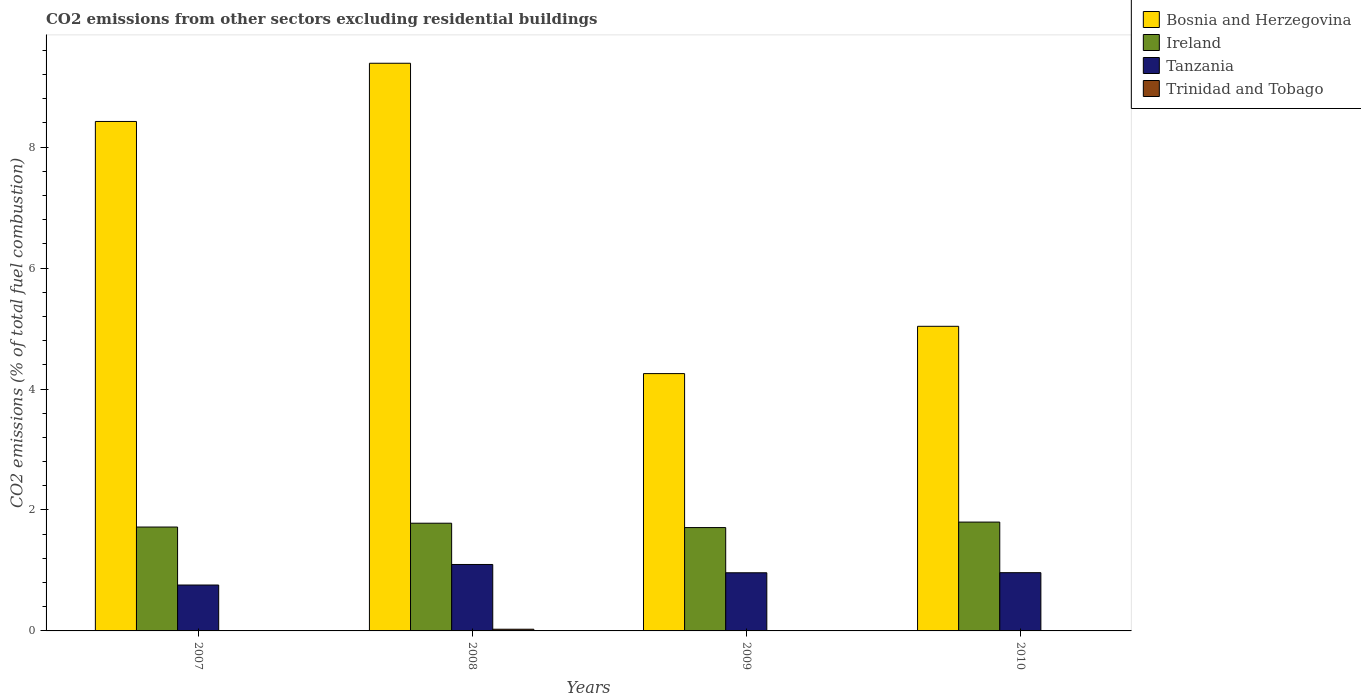How many groups of bars are there?
Provide a short and direct response. 4. What is the total CO2 emitted in Tanzania in 2007?
Offer a very short reply. 0.76. Across all years, what is the maximum total CO2 emitted in Trinidad and Tobago?
Your answer should be very brief. 0.03. Across all years, what is the minimum total CO2 emitted in Trinidad and Tobago?
Provide a succinct answer. 0. In which year was the total CO2 emitted in Trinidad and Tobago maximum?
Provide a succinct answer. 2008. What is the total total CO2 emitted in Tanzania in the graph?
Offer a very short reply. 3.78. What is the difference between the total CO2 emitted in Tanzania in 2008 and that in 2010?
Make the answer very short. 0.14. What is the difference between the total CO2 emitted in Ireland in 2008 and the total CO2 emitted in Trinidad and Tobago in 2010?
Make the answer very short. 1.78. What is the average total CO2 emitted in Trinidad and Tobago per year?
Your response must be concise. 0.01. In the year 2008, what is the difference between the total CO2 emitted in Tanzania and total CO2 emitted in Ireland?
Offer a very short reply. -0.68. What is the ratio of the total CO2 emitted in Tanzania in 2007 to that in 2009?
Your answer should be very brief. 0.79. Is the difference between the total CO2 emitted in Tanzania in 2007 and 2008 greater than the difference between the total CO2 emitted in Ireland in 2007 and 2008?
Make the answer very short. No. What is the difference between the highest and the second highest total CO2 emitted in Ireland?
Your answer should be compact. 0.02. What is the difference between the highest and the lowest total CO2 emitted in Tanzania?
Give a very brief answer. 0.34. In how many years, is the total CO2 emitted in Trinidad and Tobago greater than the average total CO2 emitted in Trinidad and Tobago taken over all years?
Your answer should be compact. 1. Is the sum of the total CO2 emitted in Tanzania in 2009 and 2010 greater than the maximum total CO2 emitted in Trinidad and Tobago across all years?
Your response must be concise. Yes. Are all the bars in the graph horizontal?
Keep it short and to the point. No. How many years are there in the graph?
Keep it short and to the point. 4. What is the difference between two consecutive major ticks on the Y-axis?
Your response must be concise. 2. Does the graph contain any zero values?
Give a very brief answer. Yes. Does the graph contain grids?
Your answer should be compact. No. Where does the legend appear in the graph?
Ensure brevity in your answer.  Top right. How many legend labels are there?
Keep it short and to the point. 4. How are the legend labels stacked?
Ensure brevity in your answer.  Vertical. What is the title of the graph?
Your response must be concise. CO2 emissions from other sectors excluding residential buildings. What is the label or title of the Y-axis?
Give a very brief answer. CO2 emissions (% of total fuel combustion). What is the CO2 emissions (% of total fuel combustion) in Bosnia and Herzegovina in 2007?
Your answer should be very brief. 8.43. What is the CO2 emissions (% of total fuel combustion) of Ireland in 2007?
Your response must be concise. 1.72. What is the CO2 emissions (% of total fuel combustion) of Tanzania in 2007?
Keep it short and to the point. 0.76. What is the CO2 emissions (% of total fuel combustion) of Trinidad and Tobago in 2007?
Your answer should be very brief. 4.75396951487204e-17. What is the CO2 emissions (% of total fuel combustion) in Bosnia and Herzegovina in 2008?
Keep it short and to the point. 9.39. What is the CO2 emissions (% of total fuel combustion) of Ireland in 2008?
Provide a succinct answer. 1.78. What is the CO2 emissions (% of total fuel combustion) in Tanzania in 2008?
Provide a succinct answer. 1.1. What is the CO2 emissions (% of total fuel combustion) of Trinidad and Tobago in 2008?
Offer a very short reply. 0.03. What is the CO2 emissions (% of total fuel combustion) in Bosnia and Herzegovina in 2009?
Keep it short and to the point. 4.26. What is the CO2 emissions (% of total fuel combustion) in Ireland in 2009?
Give a very brief answer. 1.71. What is the CO2 emissions (% of total fuel combustion) in Tanzania in 2009?
Offer a very short reply. 0.96. What is the CO2 emissions (% of total fuel combustion) of Bosnia and Herzegovina in 2010?
Your answer should be very brief. 5.04. What is the CO2 emissions (% of total fuel combustion) in Ireland in 2010?
Your answer should be compact. 1.8. What is the CO2 emissions (% of total fuel combustion) of Tanzania in 2010?
Offer a terse response. 0.96. Across all years, what is the maximum CO2 emissions (% of total fuel combustion) in Bosnia and Herzegovina?
Offer a very short reply. 9.39. Across all years, what is the maximum CO2 emissions (% of total fuel combustion) of Ireland?
Ensure brevity in your answer.  1.8. Across all years, what is the maximum CO2 emissions (% of total fuel combustion) of Tanzania?
Offer a terse response. 1.1. Across all years, what is the maximum CO2 emissions (% of total fuel combustion) of Trinidad and Tobago?
Give a very brief answer. 0.03. Across all years, what is the minimum CO2 emissions (% of total fuel combustion) of Bosnia and Herzegovina?
Your answer should be very brief. 4.26. Across all years, what is the minimum CO2 emissions (% of total fuel combustion) in Ireland?
Ensure brevity in your answer.  1.71. Across all years, what is the minimum CO2 emissions (% of total fuel combustion) of Tanzania?
Give a very brief answer. 0.76. Across all years, what is the minimum CO2 emissions (% of total fuel combustion) of Trinidad and Tobago?
Ensure brevity in your answer.  0. What is the total CO2 emissions (% of total fuel combustion) in Bosnia and Herzegovina in the graph?
Your response must be concise. 27.11. What is the total CO2 emissions (% of total fuel combustion) of Ireland in the graph?
Keep it short and to the point. 7.01. What is the total CO2 emissions (% of total fuel combustion) of Tanzania in the graph?
Make the answer very short. 3.78. What is the total CO2 emissions (% of total fuel combustion) of Trinidad and Tobago in the graph?
Provide a succinct answer. 0.03. What is the difference between the CO2 emissions (% of total fuel combustion) in Bosnia and Herzegovina in 2007 and that in 2008?
Keep it short and to the point. -0.96. What is the difference between the CO2 emissions (% of total fuel combustion) of Ireland in 2007 and that in 2008?
Give a very brief answer. -0.06. What is the difference between the CO2 emissions (% of total fuel combustion) in Tanzania in 2007 and that in 2008?
Your answer should be very brief. -0.34. What is the difference between the CO2 emissions (% of total fuel combustion) of Trinidad and Tobago in 2007 and that in 2008?
Provide a succinct answer. -0.03. What is the difference between the CO2 emissions (% of total fuel combustion) in Bosnia and Herzegovina in 2007 and that in 2009?
Ensure brevity in your answer.  4.17. What is the difference between the CO2 emissions (% of total fuel combustion) in Ireland in 2007 and that in 2009?
Offer a very short reply. 0.01. What is the difference between the CO2 emissions (% of total fuel combustion) of Tanzania in 2007 and that in 2009?
Your answer should be very brief. -0.2. What is the difference between the CO2 emissions (% of total fuel combustion) in Bosnia and Herzegovina in 2007 and that in 2010?
Keep it short and to the point. 3.39. What is the difference between the CO2 emissions (% of total fuel combustion) of Ireland in 2007 and that in 2010?
Your answer should be very brief. -0.08. What is the difference between the CO2 emissions (% of total fuel combustion) in Tanzania in 2007 and that in 2010?
Your response must be concise. -0.2. What is the difference between the CO2 emissions (% of total fuel combustion) of Bosnia and Herzegovina in 2008 and that in 2009?
Offer a terse response. 5.13. What is the difference between the CO2 emissions (% of total fuel combustion) in Ireland in 2008 and that in 2009?
Keep it short and to the point. 0.07. What is the difference between the CO2 emissions (% of total fuel combustion) of Tanzania in 2008 and that in 2009?
Keep it short and to the point. 0.14. What is the difference between the CO2 emissions (% of total fuel combustion) of Bosnia and Herzegovina in 2008 and that in 2010?
Offer a very short reply. 4.35. What is the difference between the CO2 emissions (% of total fuel combustion) in Ireland in 2008 and that in 2010?
Your response must be concise. -0.02. What is the difference between the CO2 emissions (% of total fuel combustion) in Tanzania in 2008 and that in 2010?
Ensure brevity in your answer.  0.14. What is the difference between the CO2 emissions (% of total fuel combustion) in Bosnia and Herzegovina in 2009 and that in 2010?
Ensure brevity in your answer.  -0.78. What is the difference between the CO2 emissions (% of total fuel combustion) of Ireland in 2009 and that in 2010?
Ensure brevity in your answer.  -0.09. What is the difference between the CO2 emissions (% of total fuel combustion) of Tanzania in 2009 and that in 2010?
Your answer should be compact. -0. What is the difference between the CO2 emissions (% of total fuel combustion) of Bosnia and Herzegovina in 2007 and the CO2 emissions (% of total fuel combustion) of Ireland in 2008?
Offer a very short reply. 6.64. What is the difference between the CO2 emissions (% of total fuel combustion) of Bosnia and Herzegovina in 2007 and the CO2 emissions (% of total fuel combustion) of Tanzania in 2008?
Your answer should be very brief. 7.33. What is the difference between the CO2 emissions (% of total fuel combustion) in Bosnia and Herzegovina in 2007 and the CO2 emissions (% of total fuel combustion) in Trinidad and Tobago in 2008?
Provide a succinct answer. 8.4. What is the difference between the CO2 emissions (% of total fuel combustion) of Ireland in 2007 and the CO2 emissions (% of total fuel combustion) of Tanzania in 2008?
Keep it short and to the point. 0.62. What is the difference between the CO2 emissions (% of total fuel combustion) in Ireland in 2007 and the CO2 emissions (% of total fuel combustion) in Trinidad and Tobago in 2008?
Provide a succinct answer. 1.69. What is the difference between the CO2 emissions (% of total fuel combustion) in Tanzania in 2007 and the CO2 emissions (% of total fuel combustion) in Trinidad and Tobago in 2008?
Provide a short and direct response. 0.73. What is the difference between the CO2 emissions (% of total fuel combustion) in Bosnia and Herzegovina in 2007 and the CO2 emissions (% of total fuel combustion) in Ireland in 2009?
Make the answer very short. 6.72. What is the difference between the CO2 emissions (% of total fuel combustion) in Bosnia and Herzegovina in 2007 and the CO2 emissions (% of total fuel combustion) in Tanzania in 2009?
Offer a terse response. 7.46. What is the difference between the CO2 emissions (% of total fuel combustion) of Ireland in 2007 and the CO2 emissions (% of total fuel combustion) of Tanzania in 2009?
Give a very brief answer. 0.76. What is the difference between the CO2 emissions (% of total fuel combustion) in Bosnia and Herzegovina in 2007 and the CO2 emissions (% of total fuel combustion) in Ireland in 2010?
Make the answer very short. 6.63. What is the difference between the CO2 emissions (% of total fuel combustion) in Bosnia and Herzegovina in 2007 and the CO2 emissions (% of total fuel combustion) in Tanzania in 2010?
Keep it short and to the point. 7.46. What is the difference between the CO2 emissions (% of total fuel combustion) of Ireland in 2007 and the CO2 emissions (% of total fuel combustion) of Tanzania in 2010?
Provide a succinct answer. 0.75. What is the difference between the CO2 emissions (% of total fuel combustion) of Bosnia and Herzegovina in 2008 and the CO2 emissions (% of total fuel combustion) of Ireland in 2009?
Provide a succinct answer. 7.68. What is the difference between the CO2 emissions (% of total fuel combustion) in Bosnia and Herzegovina in 2008 and the CO2 emissions (% of total fuel combustion) in Tanzania in 2009?
Offer a terse response. 8.43. What is the difference between the CO2 emissions (% of total fuel combustion) of Ireland in 2008 and the CO2 emissions (% of total fuel combustion) of Tanzania in 2009?
Give a very brief answer. 0.82. What is the difference between the CO2 emissions (% of total fuel combustion) of Bosnia and Herzegovina in 2008 and the CO2 emissions (% of total fuel combustion) of Ireland in 2010?
Give a very brief answer. 7.59. What is the difference between the CO2 emissions (% of total fuel combustion) in Bosnia and Herzegovina in 2008 and the CO2 emissions (% of total fuel combustion) in Tanzania in 2010?
Give a very brief answer. 8.42. What is the difference between the CO2 emissions (% of total fuel combustion) of Ireland in 2008 and the CO2 emissions (% of total fuel combustion) of Tanzania in 2010?
Keep it short and to the point. 0.82. What is the difference between the CO2 emissions (% of total fuel combustion) of Bosnia and Herzegovina in 2009 and the CO2 emissions (% of total fuel combustion) of Ireland in 2010?
Your answer should be very brief. 2.46. What is the difference between the CO2 emissions (% of total fuel combustion) of Bosnia and Herzegovina in 2009 and the CO2 emissions (% of total fuel combustion) of Tanzania in 2010?
Provide a short and direct response. 3.29. What is the difference between the CO2 emissions (% of total fuel combustion) in Ireland in 2009 and the CO2 emissions (% of total fuel combustion) in Tanzania in 2010?
Your response must be concise. 0.75. What is the average CO2 emissions (% of total fuel combustion) in Bosnia and Herzegovina per year?
Offer a terse response. 6.78. What is the average CO2 emissions (% of total fuel combustion) in Ireland per year?
Provide a short and direct response. 1.75. What is the average CO2 emissions (% of total fuel combustion) in Tanzania per year?
Provide a succinct answer. 0.95. What is the average CO2 emissions (% of total fuel combustion) of Trinidad and Tobago per year?
Offer a terse response. 0.01. In the year 2007, what is the difference between the CO2 emissions (% of total fuel combustion) of Bosnia and Herzegovina and CO2 emissions (% of total fuel combustion) of Ireland?
Provide a succinct answer. 6.71. In the year 2007, what is the difference between the CO2 emissions (% of total fuel combustion) in Bosnia and Herzegovina and CO2 emissions (% of total fuel combustion) in Tanzania?
Ensure brevity in your answer.  7.67. In the year 2007, what is the difference between the CO2 emissions (% of total fuel combustion) in Bosnia and Herzegovina and CO2 emissions (% of total fuel combustion) in Trinidad and Tobago?
Offer a very short reply. 8.43. In the year 2007, what is the difference between the CO2 emissions (% of total fuel combustion) in Ireland and CO2 emissions (% of total fuel combustion) in Tanzania?
Keep it short and to the point. 0.96. In the year 2007, what is the difference between the CO2 emissions (% of total fuel combustion) of Ireland and CO2 emissions (% of total fuel combustion) of Trinidad and Tobago?
Provide a short and direct response. 1.72. In the year 2007, what is the difference between the CO2 emissions (% of total fuel combustion) in Tanzania and CO2 emissions (% of total fuel combustion) in Trinidad and Tobago?
Provide a short and direct response. 0.76. In the year 2008, what is the difference between the CO2 emissions (% of total fuel combustion) in Bosnia and Herzegovina and CO2 emissions (% of total fuel combustion) in Ireland?
Your answer should be compact. 7.61. In the year 2008, what is the difference between the CO2 emissions (% of total fuel combustion) in Bosnia and Herzegovina and CO2 emissions (% of total fuel combustion) in Tanzania?
Provide a succinct answer. 8.29. In the year 2008, what is the difference between the CO2 emissions (% of total fuel combustion) of Bosnia and Herzegovina and CO2 emissions (% of total fuel combustion) of Trinidad and Tobago?
Keep it short and to the point. 9.36. In the year 2008, what is the difference between the CO2 emissions (% of total fuel combustion) of Ireland and CO2 emissions (% of total fuel combustion) of Tanzania?
Provide a succinct answer. 0.68. In the year 2008, what is the difference between the CO2 emissions (% of total fuel combustion) of Ireland and CO2 emissions (% of total fuel combustion) of Trinidad and Tobago?
Your answer should be very brief. 1.75. In the year 2008, what is the difference between the CO2 emissions (% of total fuel combustion) in Tanzania and CO2 emissions (% of total fuel combustion) in Trinidad and Tobago?
Give a very brief answer. 1.07. In the year 2009, what is the difference between the CO2 emissions (% of total fuel combustion) in Bosnia and Herzegovina and CO2 emissions (% of total fuel combustion) in Ireland?
Make the answer very short. 2.55. In the year 2009, what is the difference between the CO2 emissions (% of total fuel combustion) in Bosnia and Herzegovina and CO2 emissions (% of total fuel combustion) in Tanzania?
Provide a succinct answer. 3.29. In the year 2009, what is the difference between the CO2 emissions (% of total fuel combustion) of Ireland and CO2 emissions (% of total fuel combustion) of Tanzania?
Provide a succinct answer. 0.75. In the year 2010, what is the difference between the CO2 emissions (% of total fuel combustion) of Bosnia and Herzegovina and CO2 emissions (% of total fuel combustion) of Ireland?
Make the answer very short. 3.24. In the year 2010, what is the difference between the CO2 emissions (% of total fuel combustion) of Bosnia and Herzegovina and CO2 emissions (% of total fuel combustion) of Tanzania?
Your answer should be very brief. 4.07. In the year 2010, what is the difference between the CO2 emissions (% of total fuel combustion) of Ireland and CO2 emissions (% of total fuel combustion) of Tanzania?
Keep it short and to the point. 0.84. What is the ratio of the CO2 emissions (% of total fuel combustion) in Bosnia and Herzegovina in 2007 to that in 2008?
Offer a very short reply. 0.9. What is the ratio of the CO2 emissions (% of total fuel combustion) of Ireland in 2007 to that in 2008?
Make the answer very short. 0.96. What is the ratio of the CO2 emissions (% of total fuel combustion) of Tanzania in 2007 to that in 2008?
Offer a terse response. 0.69. What is the ratio of the CO2 emissions (% of total fuel combustion) in Bosnia and Herzegovina in 2007 to that in 2009?
Offer a terse response. 1.98. What is the ratio of the CO2 emissions (% of total fuel combustion) in Tanzania in 2007 to that in 2009?
Your answer should be compact. 0.79. What is the ratio of the CO2 emissions (% of total fuel combustion) of Bosnia and Herzegovina in 2007 to that in 2010?
Give a very brief answer. 1.67. What is the ratio of the CO2 emissions (% of total fuel combustion) of Ireland in 2007 to that in 2010?
Your answer should be very brief. 0.95. What is the ratio of the CO2 emissions (% of total fuel combustion) of Tanzania in 2007 to that in 2010?
Give a very brief answer. 0.79. What is the ratio of the CO2 emissions (% of total fuel combustion) in Bosnia and Herzegovina in 2008 to that in 2009?
Your response must be concise. 2.21. What is the ratio of the CO2 emissions (% of total fuel combustion) in Ireland in 2008 to that in 2009?
Make the answer very short. 1.04. What is the ratio of the CO2 emissions (% of total fuel combustion) in Tanzania in 2008 to that in 2009?
Your answer should be very brief. 1.14. What is the ratio of the CO2 emissions (% of total fuel combustion) of Bosnia and Herzegovina in 2008 to that in 2010?
Your answer should be very brief. 1.86. What is the ratio of the CO2 emissions (% of total fuel combustion) in Ireland in 2008 to that in 2010?
Provide a succinct answer. 0.99. What is the ratio of the CO2 emissions (% of total fuel combustion) of Tanzania in 2008 to that in 2010?
Your response must be concise. 1.14. What is the ratio of the CO2 emissions (% of total fuel combustion) in Bosnia and Herzegovina in 2009 to that in 2010?
Give a very brief answer. 0.84. What is the ratio of the CO2 emissions (% of total fuel combustion) of Ireland in 2009 to that in 2010?
Make the answer very short. 0.95. What is the difference between the highest and the second highest CO2 emissions (% of total fuel combustion) of Bosnia and Herzegovina?
Make the answer very short. 0.96. What is the difference between the highest and the second highest CO2 emissions (% of total fuel combustion) of Ireland?
Provide a succinct answer. 0.02. What is the difference between the highest and the second highest CO2 emissions (% of total fuel combustion) in Tanzania?
Make the answer very short. 0.14. What is the difference between the highest and the lowest CO2 emissions (% of total fuel combustion) in Bosnia and Herzegovina?
Give a very brief answer. 5.13. What is the difference between the highest and the lowest CO2 emissions (% of total fuel combustion) in Ireland?
Offer a very short reply. 0.09. What is the difference between the highest and the lowest CO2 emissions (% of total fuel combustion) of Tanzania?
Your response must be concise. 0.34. What is the difference between the highest and the lowest CO2 emissions (% of total fuel combustion) of Trinidad and Tobago?
Provide a short and direct response. 0.03. 